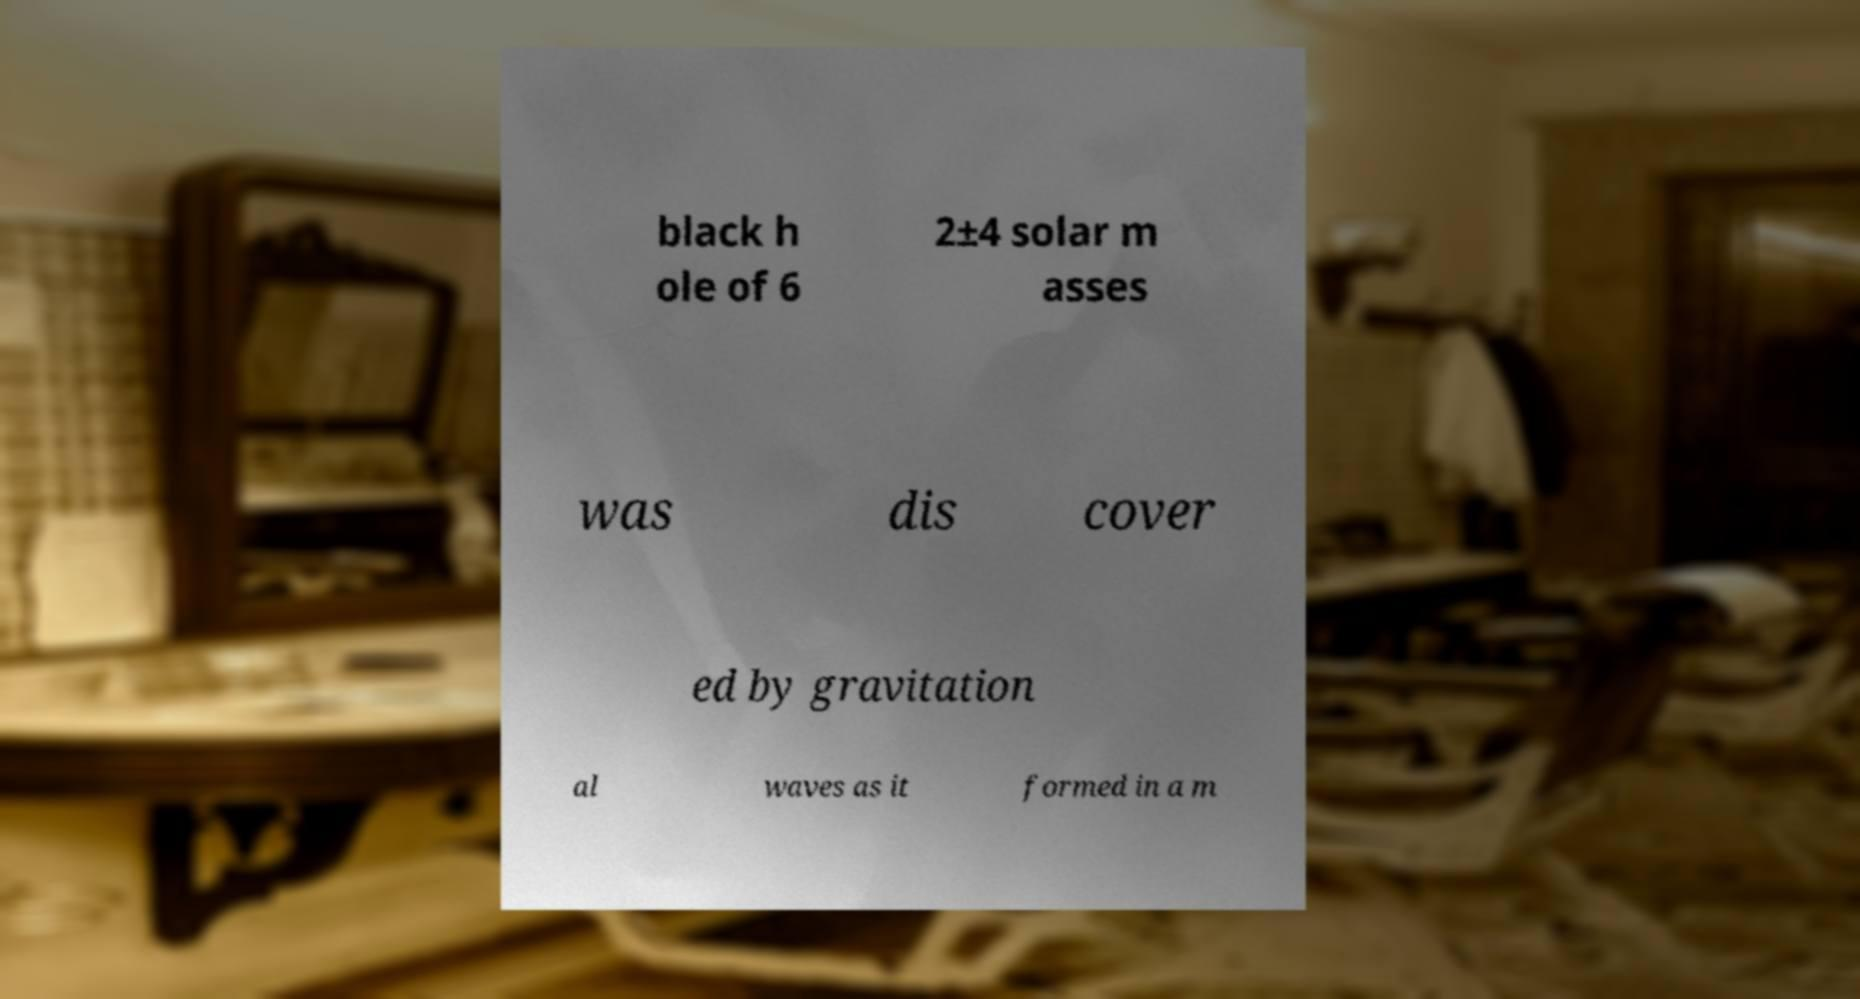Can you accurately transcribe the text from the provided image for me? black h ole of 6 2±4 solar m asses was dis cover ed by gravitation al waves as it formed in a m 